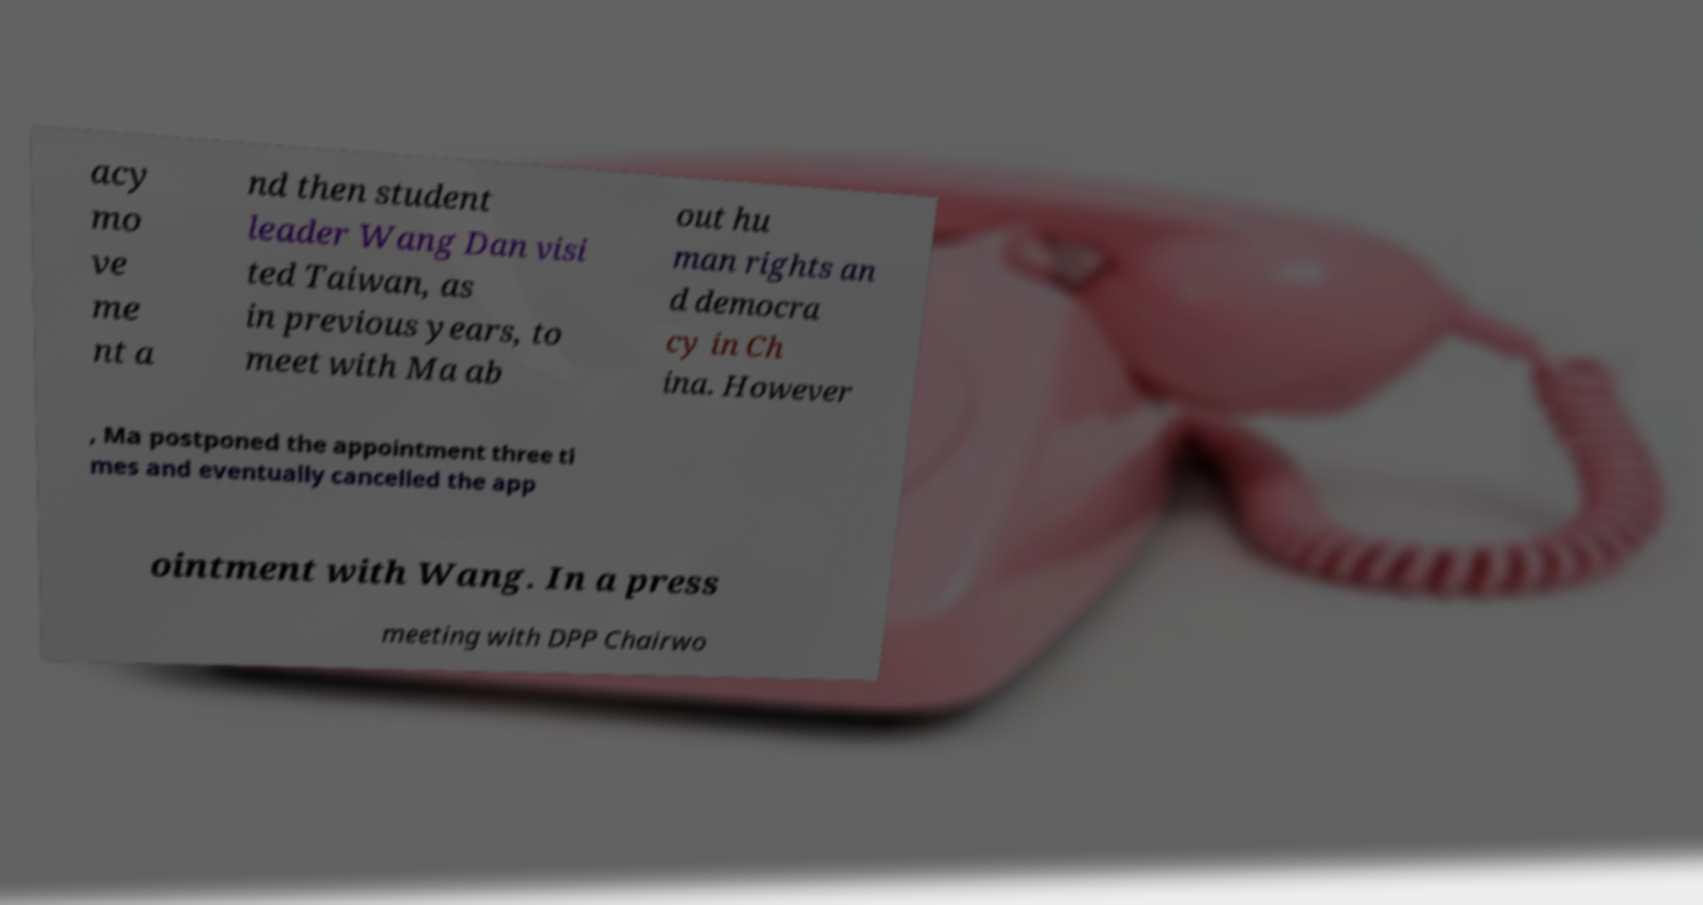There's text embedded in this image that I need extracted. Can you transcribe it verbatim? acy mo ve me nt a nd then student leader Wang Dan visi ted Taiwan, as in previous years, to meet with Ma ab out hu man rights an d democra cy in Ch ina. However , Ma postponed the appointment three ti mes and eventually cancelled the app ointment with Wang. In a press meeting with DPP Chairwo 